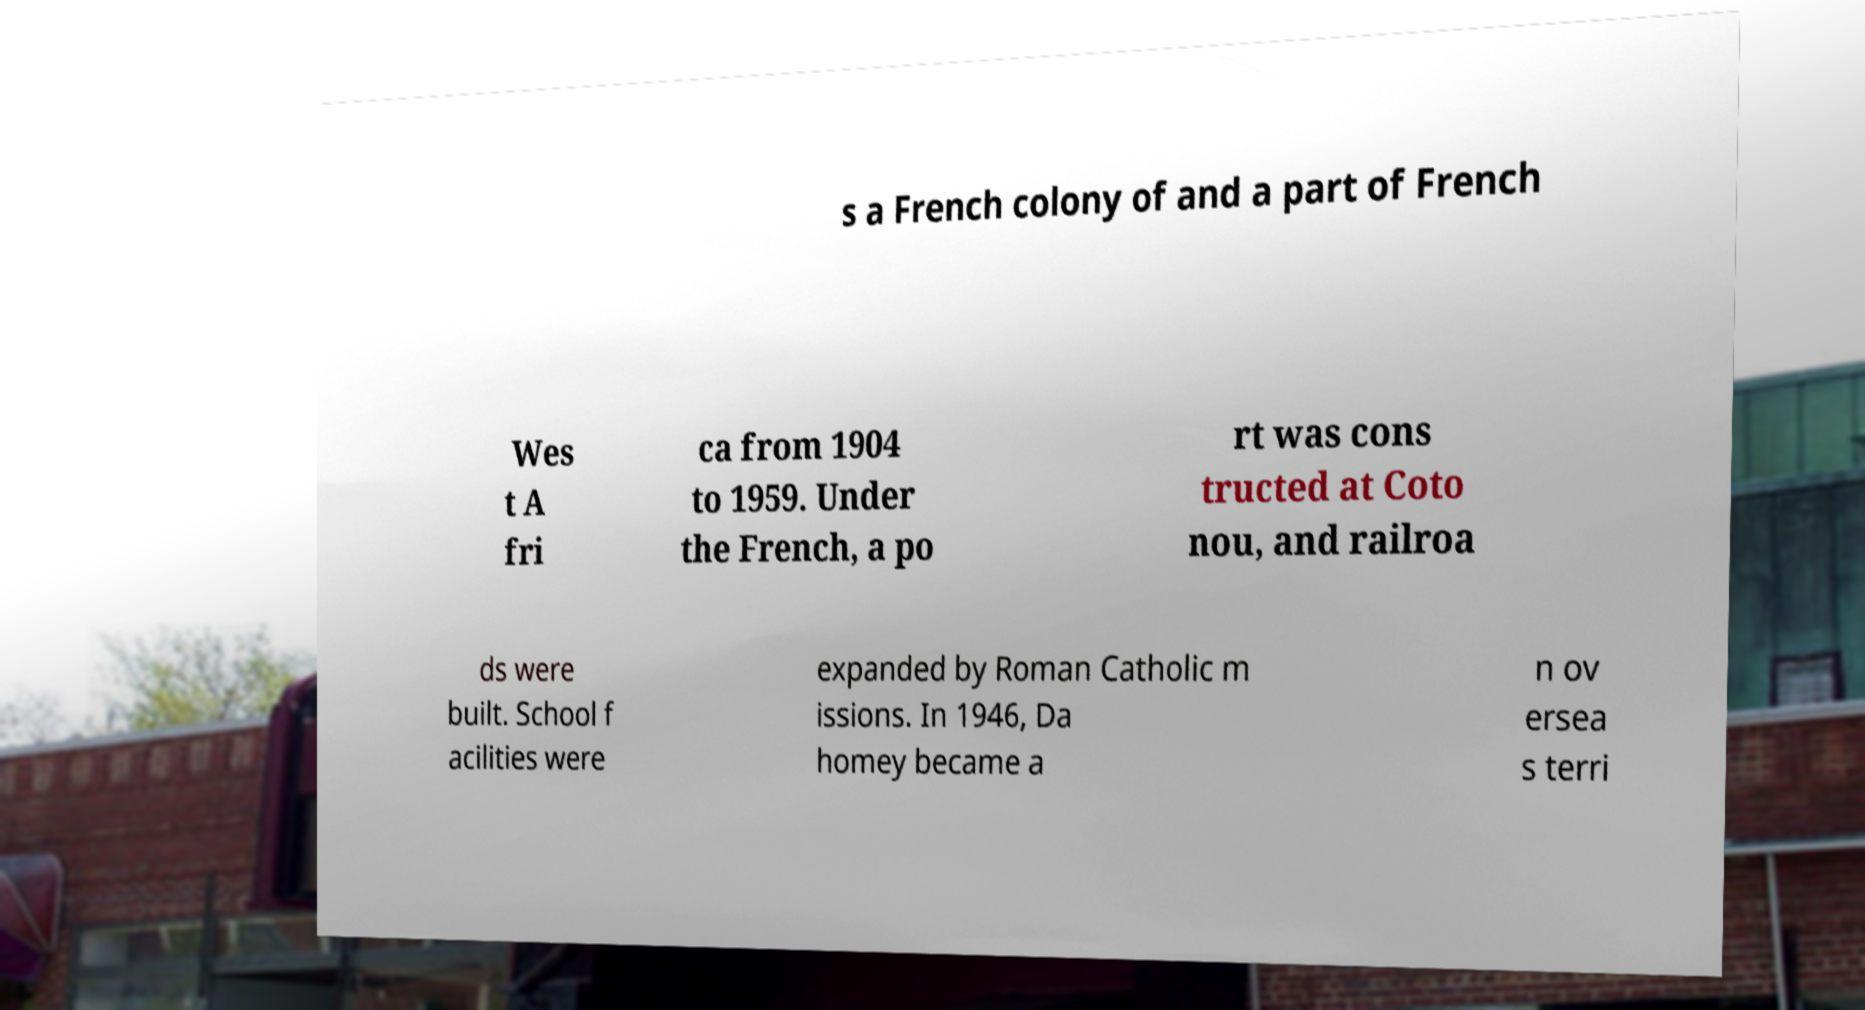Please read and relay the text visible in this image. What does it say? s a French colony of and a part of French Wes t A fri ca from 1904 to 1959. Under the French, a po rt was cons tructed at Coto nou, and railroa ds were built. School f acilities were expanded by Roman Catholic m issions. In 1946, Da homey became a n ov ersea s terri 